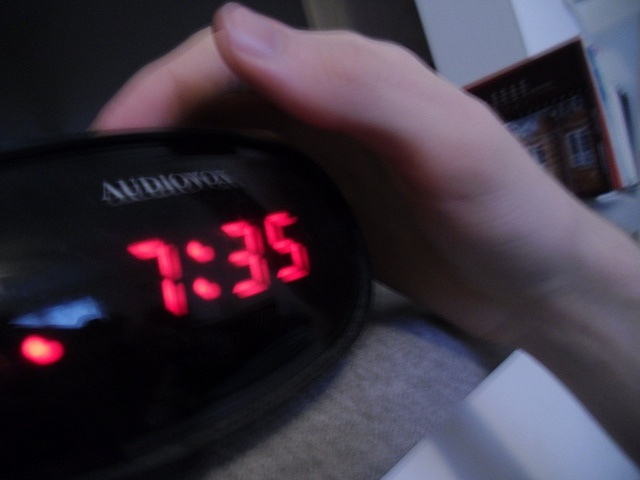Describe the objects in this image and their specific colors. I can see people in black and gray tones, clock in black, brown, and maroon tones, book in black and gray tones, and book in black, gray, and navy tones in this image. 